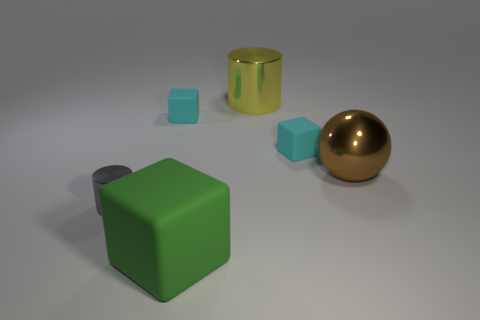There is a small object that is to the right of the small cyan matte cube that is on the left side of the large yellow metallic cylinder; what number of large green rubber blocks are behind it?
Make the answer very short. 0. Does the cyan block on the right side of the yellow object have the same size as the large yellow cylinder?
Offer a terse response. No. What number of gray things are behind the tiny matte object that is to the left of the large green matte object?
Ensure brevity in your answer.  0. There is a tiny cyan object behind the block that is to the right of the yellow metallic cylinder; are there any large brown metal balls that are in front of it?
Your response must be concise. Yes. Are the yellow object and the big object that is in front of the large brown ball made of the same material?
Make the answer very short. No. There is a metallic thing behind the tiny matte object that is to the right of the yellow shiny object; what shape is it?
Your answer should be very brief. Cylinder. What number of large objects are yellow objects or metallic balls?
Ensure brevity in your answer.  2. What number of other gray things are the same shape as the gray object?
Your answer should be compact. 0. Do the large matte object and the large metal thing that is to the right of the big metallic cylinder have the same shape?
Your answer should be compact. No. How many tiny gray metal cylinders are on the left side of the large green matte object?
Your answer should be compact. 1. 